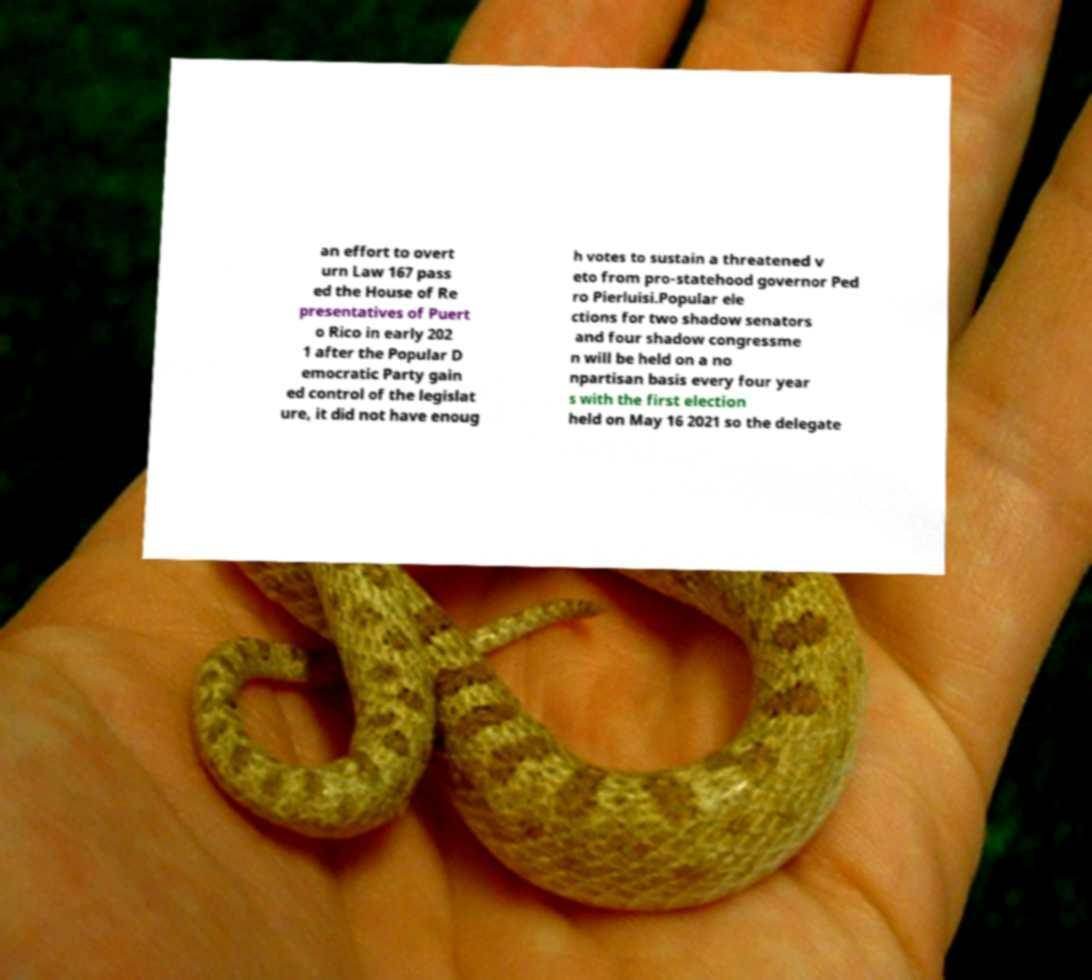Could you assist in decoding the text presented in this image and type it out clearly? an effort to overt urn Law 167 pass ed the House of Re presentatives of Puert o Rico in early 202 1 after the Popular D emocratic Party gain ed control of the legislat ure, it did not have enoug h votes to sustain a threatened v eto from pro-statehood governor Ped ro Pierluisi.Popular ele ctions for two shadow senators and four shadow congressme n will be held on a no npartisan basis every four year s with the first election held on May 16 2021 so the delegate 